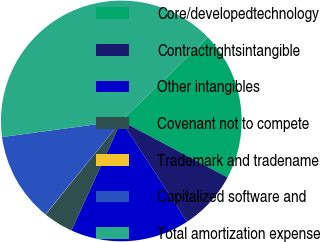Convert chart to OTSL. <chart><loc_0><loc_0><loc_500><loc_500><pie_chart><fcel>Core/developedtechnology<fcel>Contractrightsintangible<fcel>Other intangibles<fcel>Covenant not to compete<fcel>Trademark and tradename<fcel>Capitalized software and<fcel>Total amortization expense<nl><fcel>19.99%<fcel>8.02%<fcel>16.0%<fcel>4.03%<fcel>0.03%<fcel>12.01%<fcel>39.94%<nl></chart> 